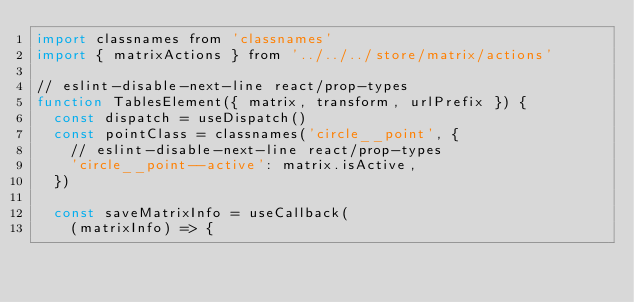Convert code to text. <code><loc_0><loc_0><loc_500><loc_500><_JavaScript_>import classnames from 'classnames'
import { matrixActions } from '../../../store/matrix/actions'

// eslint-disable-next-line react/prop-types
function TablesElement({ matrix, transform, urlPrefix }) {
  const dispatch = useDispatch()
  const pointClass = classnames('circle__point', {
    // eslint-disable-next-line react/prop-types
    'circle__point--active': matrix.isActive,
  })

  const saveMatrixInfo = useCallback(
    (matrixInfo) => {</code> 